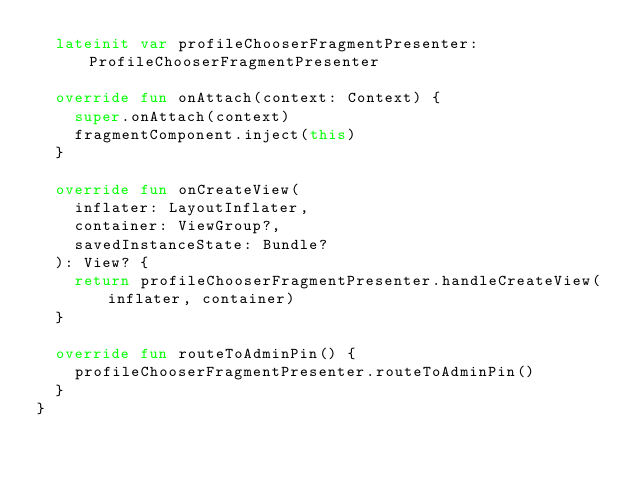Convert code to text. <code><loc_0><loc_0><loc_500><loc_500><_Kotlin_>  lateinit var profileChooserFragmentPresenter: ProfileChooserFragmentPresenter

  override fun onAttach(context: Context) {
    super.onAttach(context)
    fragmentComponent.inject(this)
  }

  override fun onCreateView(
    inflater: LayoutInflater,
    container: ViewGroup?,
    savedInstanceState: Bundle?
  ): View? {
    return profileChooserFragmentPresenter.handleCreateView(inflater, container)
  }

  override fun routeToAdminPin() {
    profileChooserFragmentPresenter.routeToAdminPin()
  }
}
</code> 